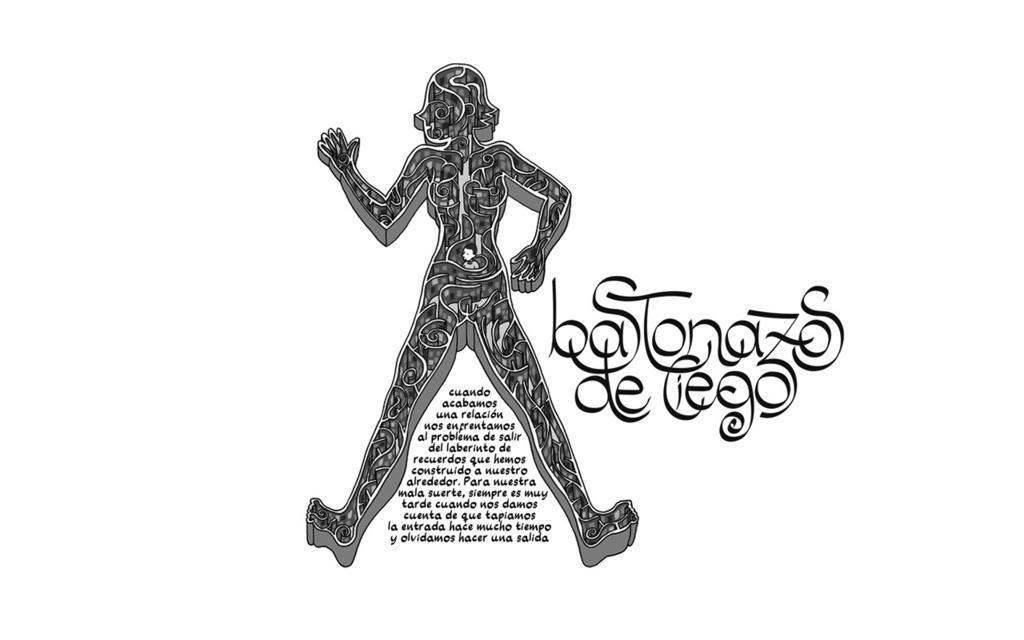In one or two sentences, can you explain what this image depicts? In this image there is a painted picture. Middle of the image there is a painting of a person. There is some text. Background is in white color. 